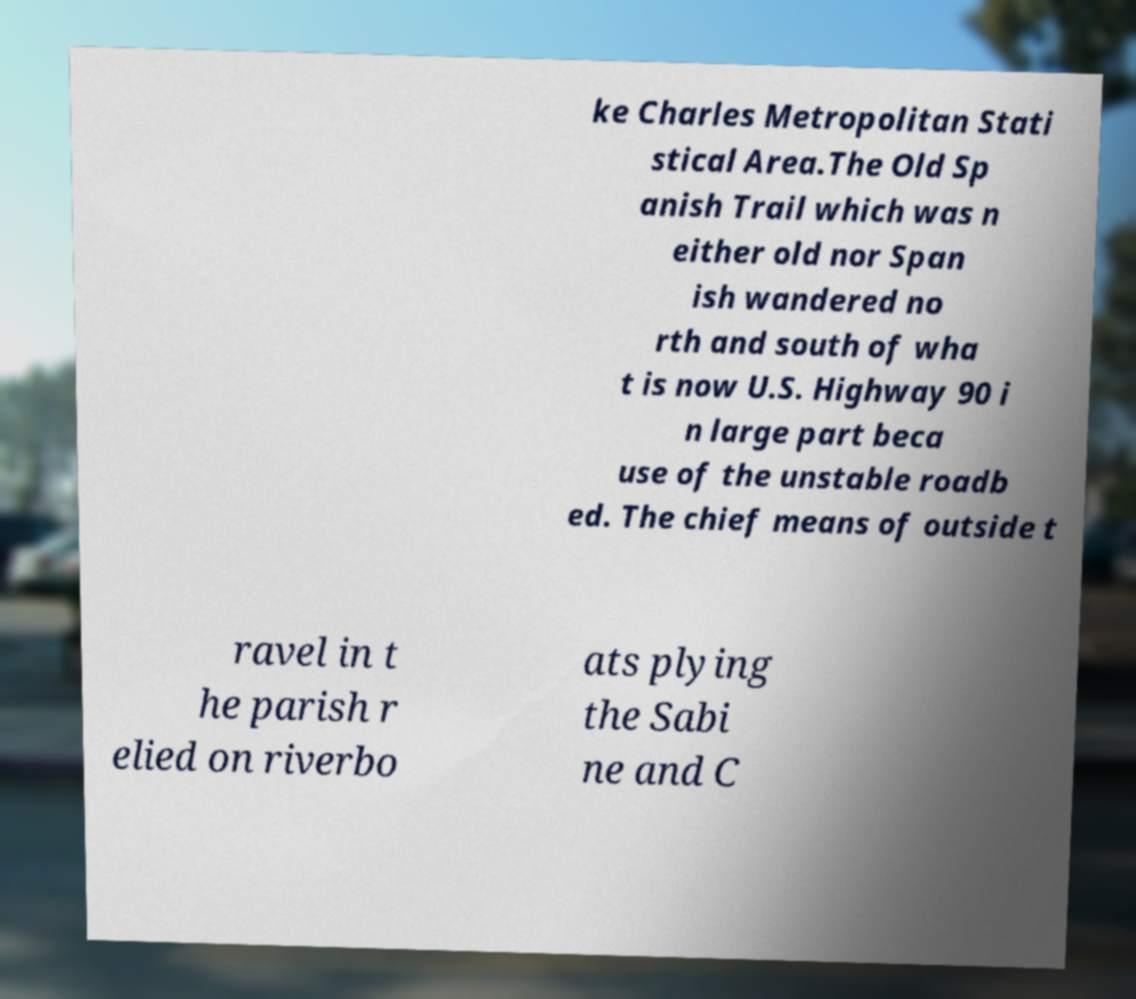What messages or text are displayed in this image? I need them in a readable, typed format. ke Charles Metropolitan Stati stical Area.The Old Sp anish Trail which was n either old nor Span ish wandered no rth and south of wha t is now U.S. Highway 90 i n large part beca use of the unstable roadb ed. The chief means of outside t ravel in t he parish r elied on riverbo ats plying the Sabi ne and C 